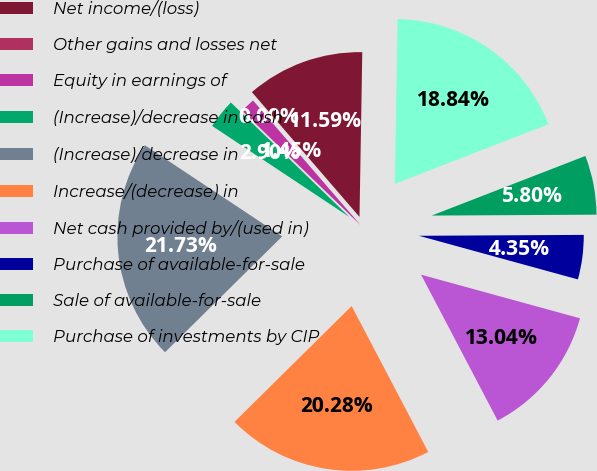Convert chart to OTSL. <chart><loc_0><loc_0><loc_500><loc_500><pie_chart><fcel>Net income/(loss)<fcel>Other gains and losses net<fcel>Equity in earnings of<fcel>(Increase)/decrease in cash<fcel>(Increase)/decrease in<fcel>Increase/(decrease) in<fcel>Net cash provided by/(used in)<fcel>Purchase of available-for-sale<fcel>Sale of available-for-sale<fcel>Purchase of investments by CIP<nl><fcel>11.59%<fcel>0.0%<fcel>1.45%<fcel>2.9%<fcel>21.73%<fcel>20.28%<fcel>13.04%<fcel>4.35%<fcel>5.8%<fcel>18.84%<nl></chart> 